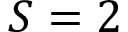Convert formula to latex. <formula><loc_0><loc_0><loc_500><loc_500>S = 2</formula> 